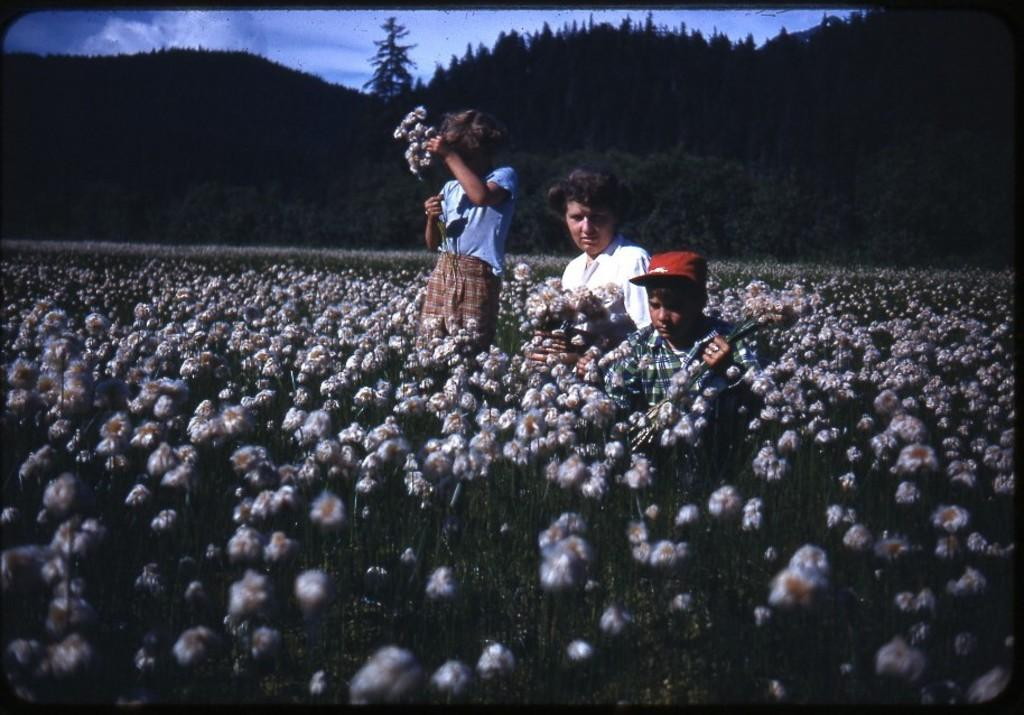How many people are in the image? There are three persons in the image. Where are the persons located in the image? The three persons are in a flower garden. What are the persons holding in their hands? The persons are holding flowers in their hands. What can be seen in the background of the image? There are trees in the background of the image. What type of robin can be seen swimming in the flower garden in the image? There is no robin present in the image, and robins do not swim. 